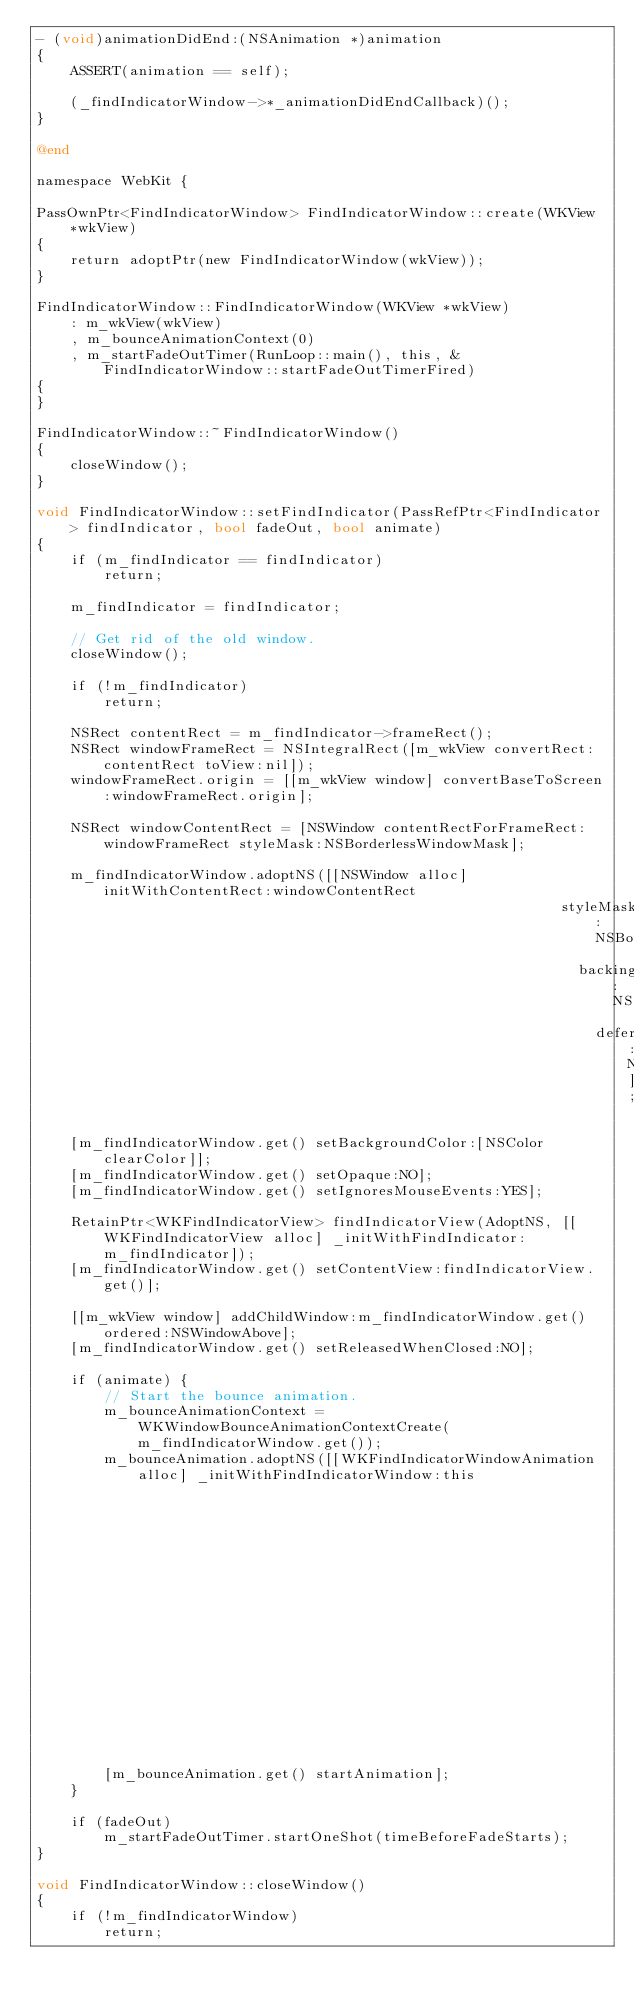Convert code to text. <code><loc_0><loc_0><loc_500><loc_500><_ObjectiveC_>- (void)animationDidEnd:(NSAnimation *)animation
{
    ASSERT(animation == self);

    (_findIndicatorWindow->*_animationDidEndCallback)();
}

@end

namespace WebKit {

PassOwnPtr<FindIndicatorWindow> FindIndicatorWindow::create(WKView *wkView)
{
    return adoptPtr(new FindIndicatorWindow(wkView));
}

FindIndicatorWindow::FindIndicatorWindow(WKView *wkView)
    : m_wkView(wkView)
    , m_bounceAnimationContext(0)
    , m_startFadeOutTimer(RunLoop::main(), this, &FindIndicatorWindow::startFadeOutTimerFired)
{
}

FindIndicatorWindow::~FindIndicatorWindow()
{
    closeWindow();
}

void FindIndicatorWindow::setFindIndicator(PassRefPtr<FindIndicator> findIndicator, bool fadeOut, bool animate)
{
    if (m_findIndicator == findIndicator)
        return;

    m_findIndicator = findIndicator;

    // Get rid of the old window.
    closeWindow();

    if (!m_findIndicator)
        return;

    NSRect contentRect = m_findIndicator->frameRect();
    NSRect windowFrameRect = NSIntegralRect([m_wkView convertRect:contentRect toView:nil]);
    windowFrameRect.origin = [[m_wkView window] convertBaseToScreen:windowFrameRect.origin];

    NSRect windowContentRect = [NSWindow contentRectForFrameRect:windowFrameRect styleMask:NSBorderlessWindowMask];
    
    m_findIndicatorWindow.adoptNS([[NSWindow alloc] initWithContentRect:windowContentRect 
                                                              styleMask:NSBorderlessWindowMask 
                                                                backing:NSBackingStoreBuffered
                                                                  defer:NO]);

    [m_findIndicatorWindow.get() setBackgroundColor:[NSColor clearColor]];
    [m_findIndicatorWindow.get() setOpaque:NO];
    [m_findIndicatorWindow.get() setIgnoresMouseEvents:YES];

    RetainPtr<WKFindIndicatorView> findIndicatorView(AdoptNS, [[WKFindIndicatorView alloc] _initWithFindIndicator:m_findIndicator]);
    [m_findIndicatorWindow.get() setContentView:findIndicatorView.get()];

    [[m_wkView window] addChildWindow:m_findIndicatorWindow.get() ordered:NSWindowAbove];
    [m_findIndicatorWindow.get() setReleasedWhenClosed:NO];

    if (animate) {
        // Start the bounce animation.
        m_bounceAnimationContext = WKWindowBounceAnimationContextCreate(m_findIndicatorWindow.get());
        m_bounceAnimation.adoptNS([[WKFindIndicatorWindowAnimation alloc] _initWithFindIndicatorWindow:this
                                                                                    animationDuration:bounceAnimationDuration
                                                                            animationProgressCallback:&FindIndicatorWindow::bounceAnimationCallback
                                                                              animationDidEndCallback:&FindIndicatorWindow::bounceAnimationDidEnd]);
        [m_bounceAnimation.get() startAnimation];
    }

    if (fadeOut)
        m_startFadeOutTimer.startOneShot(timeBeforeFadeStarts);
}

void FindIndicatorWindow::closeWindow()
{
    if (!m_findIndicatorWindow)
        return;
</code> 